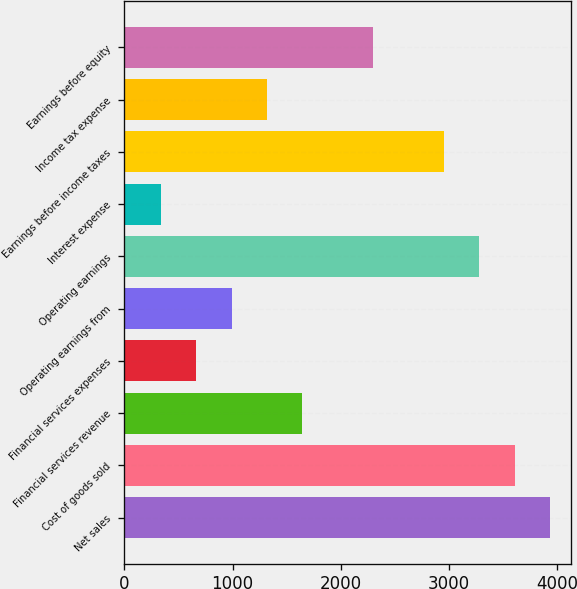<chart> <loc_0><loc_0><loc_500><loc_500><bar_chart><fcel>Net sales<fcel>Cost of goods sold<fcel>Financial services revenue<fcel>Financial services expenses<fcel>Operating earnings from<fcel>Operating earnings<fcel>Interest expense<fcel>Earnings before income taxes<fcel>Income tax expense<fcel>Earnings before equity<nl><fcel>3931.2<fcel>3604.45<fcel>1643.95<fcel>663.7<fcel>990.45<fcel>3277.7<fcel>336.95<fcel>2950.95<fcel>1317.2<fcel>2297.45<nl></chart> 